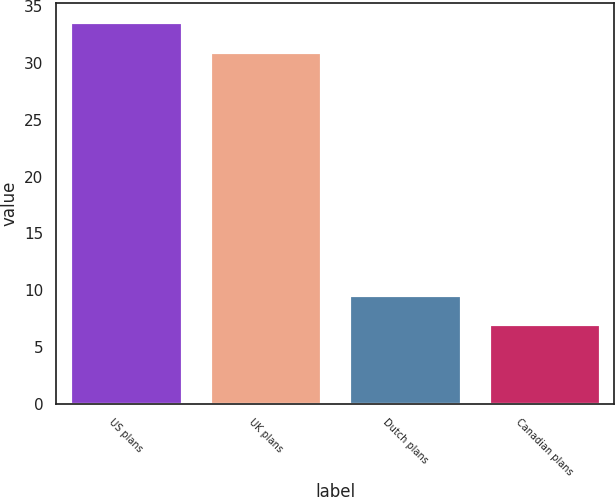Convert chart. <chart><loc_0><loc_0><loc_500><loc_500><bar_chart><fcel>US plans<fcel>UK plans<fcel>Dutch plans<fcel>Canadian plans<nl><fcel>33.6<fcel>31<fcel>9.6<fcel>7<nl></chart> 